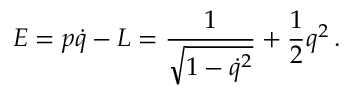Convert formula to latex. <formula><loc_0><loc_0><loc_500><loc_500>E = p \dot { q } - L = { \frac { 1 } { \sqrt { 1 - \dot { q } ^ { 2 } } } } + { \frac { 1 } { 2 } } q ^ { 2 } \, .</formula> 